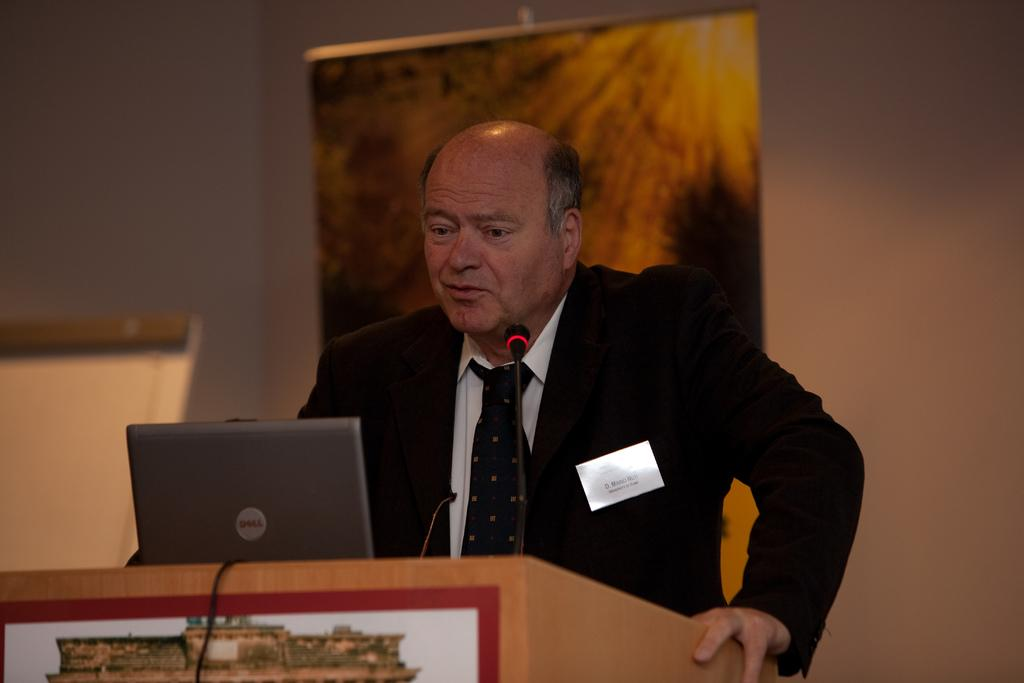What is the man in the image doing? The man is standing at the podium. What items are on the podium with the man? A laptop and a microphone are on the podium. What can be seen in the background of the image? There is a wall, a hoarding, and an object visible in the background. What type of wren can be seen flying around the man in the image? There is no wren present in the image; it only features a man at a podium, a laptop, a microphone, and elements in the background. 